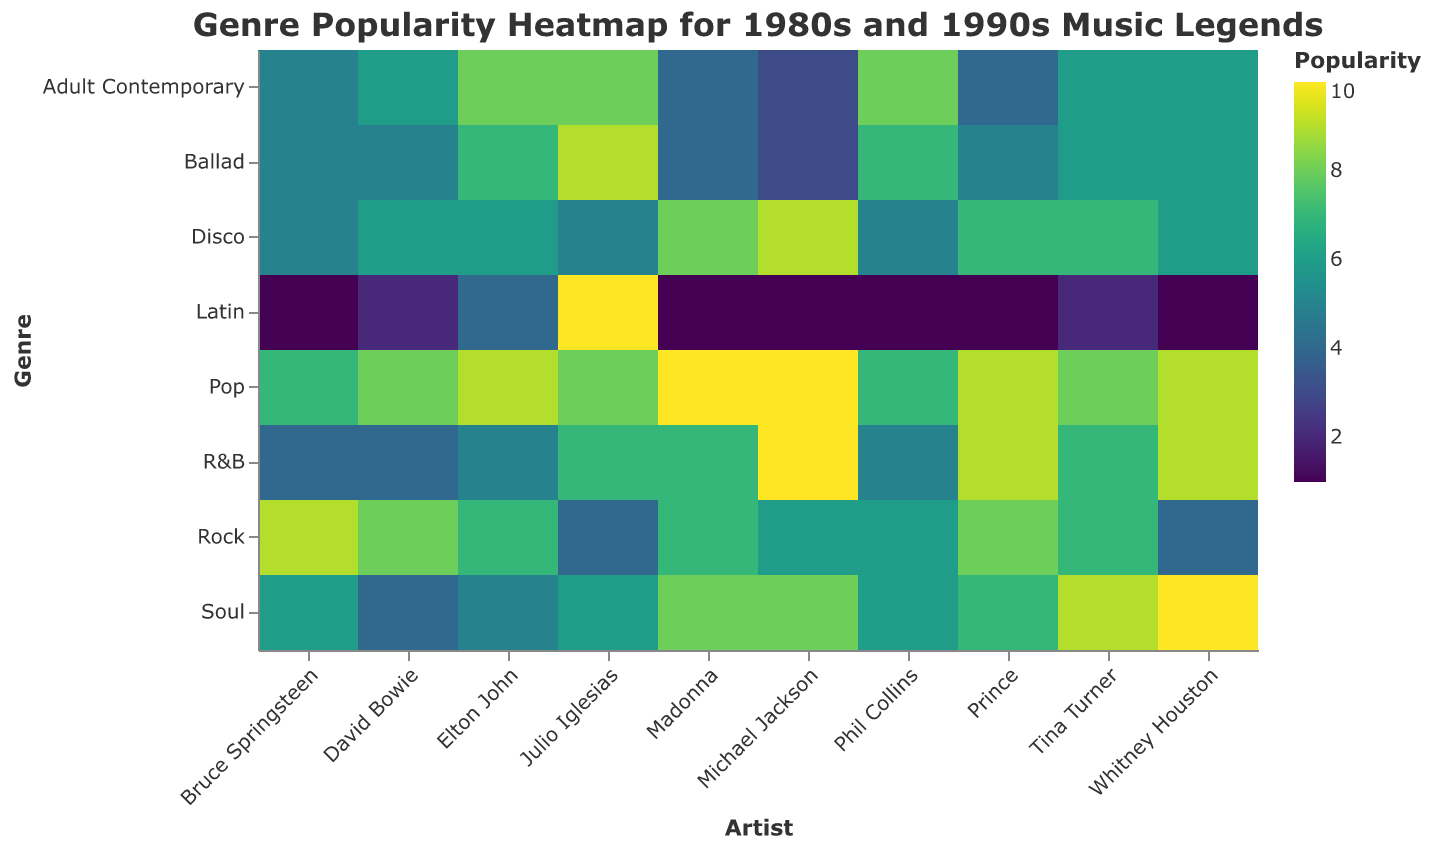What is the title of the heatmap? The title is located at the top of the figure and is clearly stated in a readable font.
Answer: Genre Popularity Heatmap for 1980s and 1990s Music Legends Which genre has the highest popularity score for Julio Iglesias? By examining the row corresponding to Julio Iglesias, note the highest shaded cell within the column.
Answer: Latin Who has the highest popularity score in the genre of Soul? Look at the row labeled "Soul" and identify the artist with the darkest shaded cell.
Answer: Whitney Houston Compare the popularity scores of Michael Jackson and Madonna in the Pop genre. Who has a higher score? Look at the column for Michael Jackson and Madonna in the "Pop" row and compare the two color intensities.
Answer: Neither, both have a score of 10 Is Rock more popular for Bruce Springsteen or Phil Collins? Examine the cells in the "Rock" row for Bruce Springsteen and Phil Collins and compare the color intensities.
Answer: Bruce Springsteen How does Julio Iglesias' popularity in Ballad compare to Whitney Houston's? Examine the "Ballad" row for the cells corresponding to Julio Iglesias and Whitney Houston and compare the color intensities.
Answer: Higher What is the average popularity score of Elton John across all genres? Sum up the popularity values for Elton John across all rows and divide by the number of genres (8). 9+7+4+5+6+5+8+7 = 51, then 51/8 = 6.375
Answer: 6.375 Who has the least popularity in the Latin genre? Look at the cells in the "Latin" row and identify the artist with the lightest shaded cell, indicating the lowest value.
Answer: Michael Jackson, Madonna, Whitney Houston, Prince, Bruce Springsteen, Phil Collins Which artist has the highest average popularity across all genres? Sum the popularity scores for each artist across all genres and divide by the number of genres, then compare these averages. Michael Jackson: 56, Madonna: 50, Whitney Houston: 55, Prince: 50, Bruce Springsteen: 42, Elton John: 51, David Bowie: 43, Tina Turner: 52, Phil Collins: 45, Julio Iglesias: 57.
Answer: Julio Iglesias If you sum the Pop and Disco popularity scores of David Bowie, what do you get? Add the popularity values of David Bowie in the Pop and Disco rows. 8 + 6 = 14
Answer: 14 